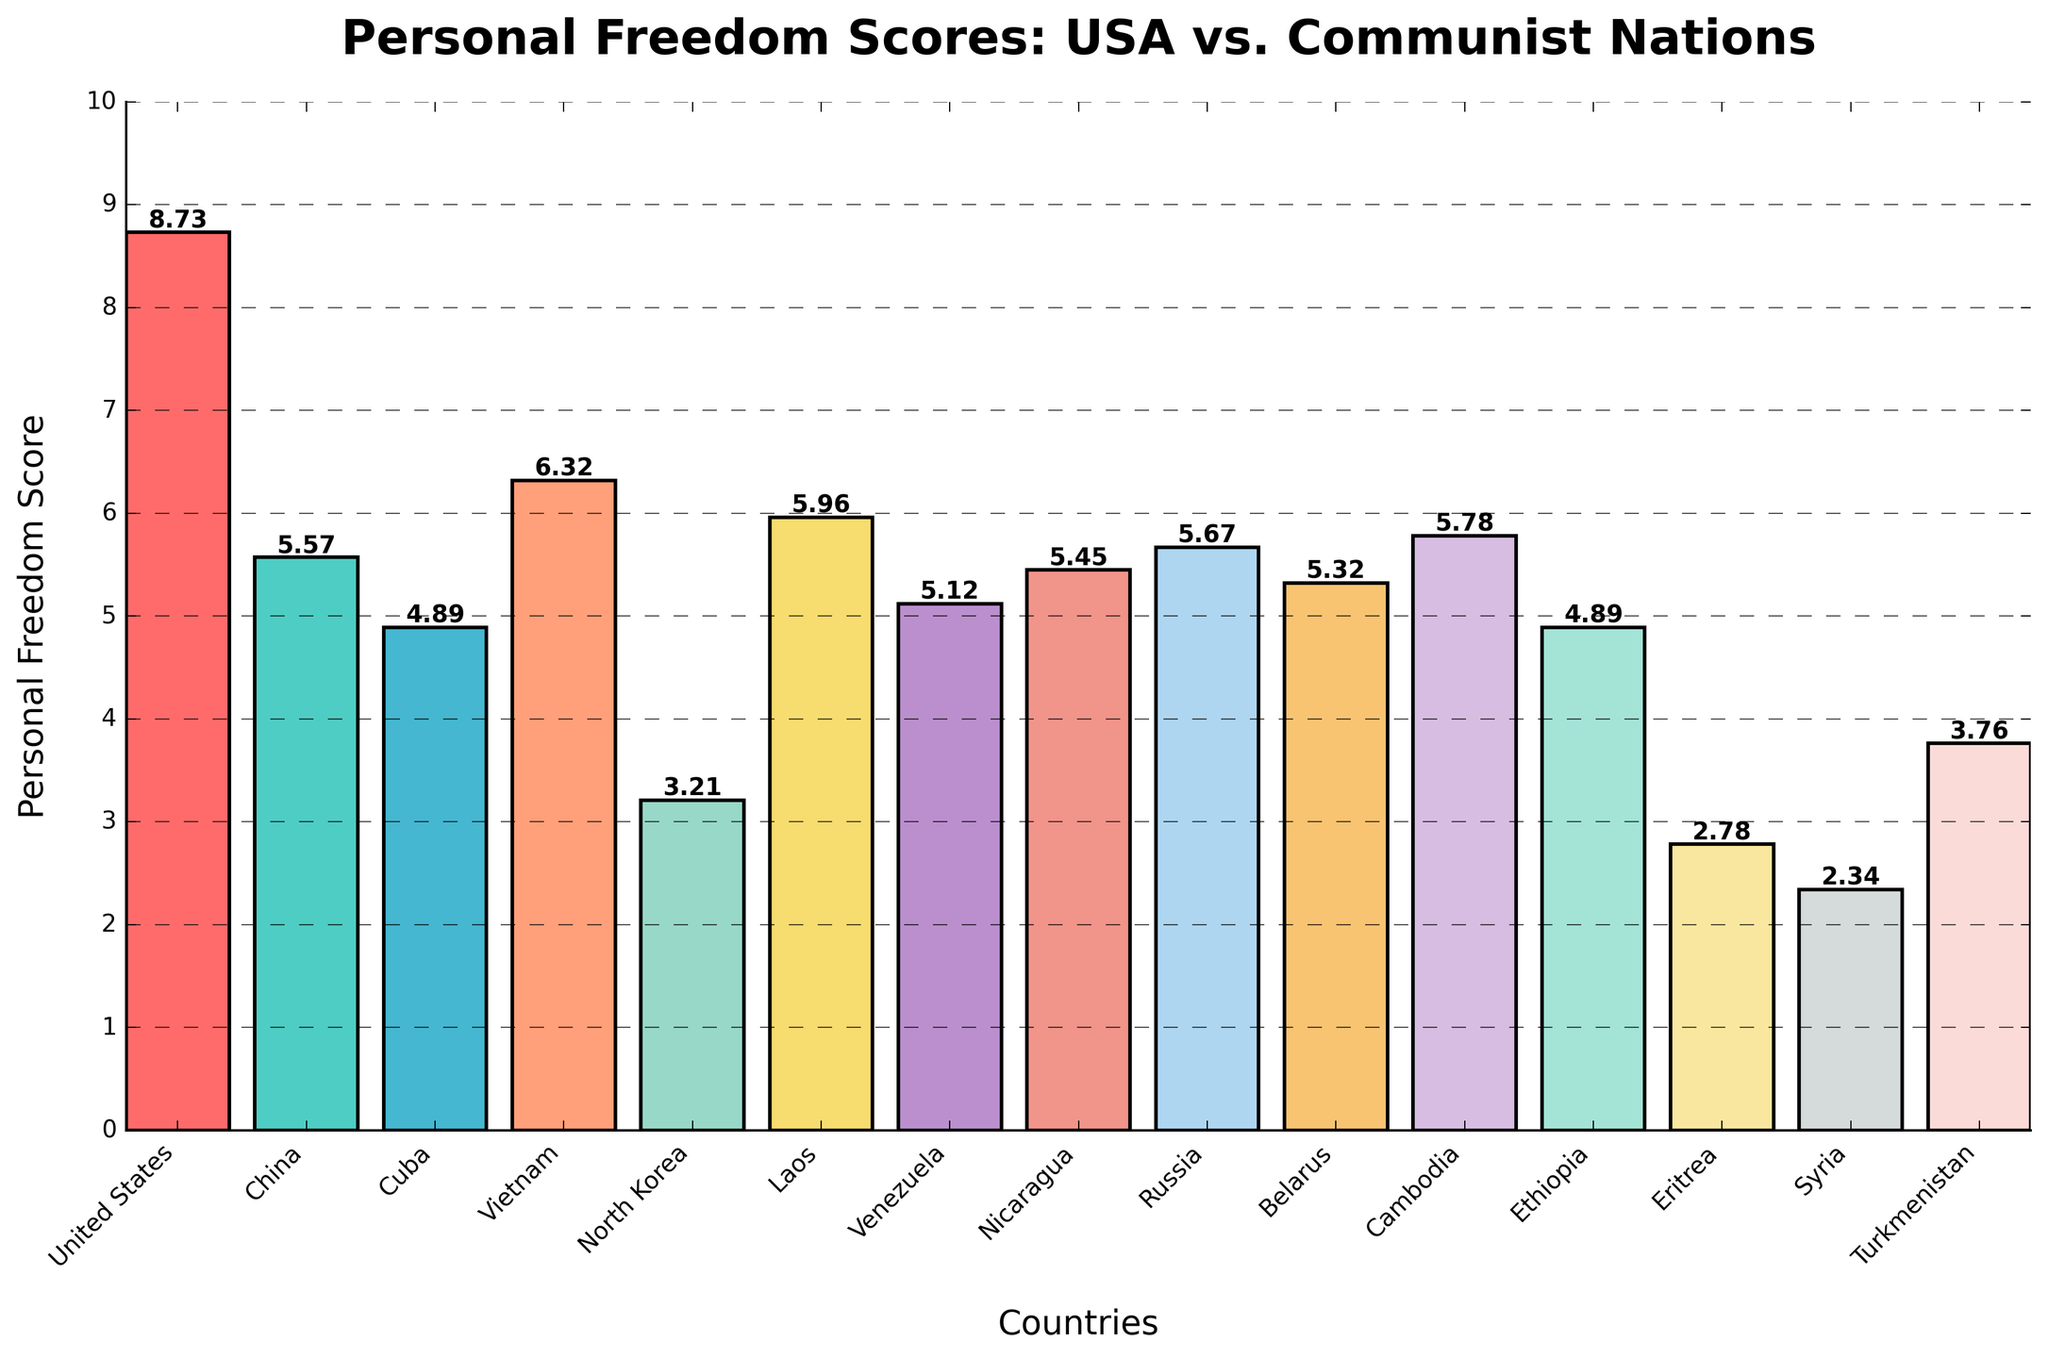What's the highest personal freedom score indicated on the chart and which country does it belong to? By looking at the bar with the greatest height, we see that the United States has the highest personal freedom score. The exact value next to the top of the bar for the US is 8.73.
Answer: 8.73, United States How does North Korea's personal freedom score compare to that of China? By comparing the heights of the bars, North Korea’s bar is significantly shorter than China’s. The exact scores are indicated as 3.21 for North Korea and 5.57 for China. Therefore, North Korea's score is lower.
Answer: Lower Is there any country with a personal freedom score lower than Syria? By examining the heights of the bars, the shortest bar represents Eritrea with a score of 2.78, which is higher than Syria's bar that indicates a score of 2.34. Thus, Syria has the lowest score.
Answer: No What is the combined personal freedom score of Cuba and Vietnam? The scores for Cuba and Vietnam are 4.89 and 6.32 respectively. The combined score is the sum of these two values: 4.89 + 6.32 = 11.21.
Answer: 11.21 Which country has the third-highest personal freedom score? By observing the heights of the bars and their respective scores, the top three scores are from the United States (8.73), Vietnam (6.32), and Cambodia (5.78). Thus, Cambodia has the third-highest score.
Answer: Cambodia What is the average personal freedom score of Laos, Venezuela, and Nicaragua? The scores are 5.96 for Laos, 5.12 for Venezuela, and 5.45 for Nicaragua. To find the average, add these three scores and divide by 3: (5.96 + 5.12 + 5.45) / 3 = 5.51.
Answer: 5.51 What is the difference in personal freedom scores between Turkmenistan and Ethiopia? Turkmenistan has a score of 3.76 and Ethiopia has a score of 4.89. The difference is calculated as 4.89 - 3.76 = 1.13.
Answer: 1.13 Which country has a personal freedom score most similar to Russia and what is that score? Russia has a personal freedom score of 5.67. By comparing the scores, Cambodia has a score of 5.78, which is the closest to Russia's score.
Answer: Cambodia, 5.78 What is the median personal freedom score of the countries listed? To find the median, we must first list all the scores in ascending order: 2.34 (Syria), 2.78 (Eritrea), 3.21 (North Korea), 3.76 (Turkmenistan), 4.89 (Cuba and Ethiopia), 5.12 (Venezuela), 5.32 (Belarus),  5.45 (Nicaragua), 5.57 (China), 5.67 (Russia), 5.78 (Cambodia), 5.96 (Laos), 6.32 (Vietnam), 8.73 (United States). The median is the middle value; in this case, it is the average of the 7th and 8th values: (5.32 + 5.45) / 2 = 5.385.
Answer: 5.39 